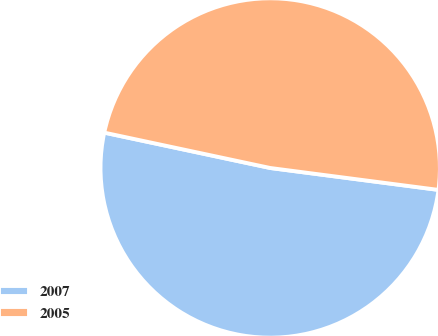<chart> <loc_0><loc_0><loc_500><loc_500><pie_chart><fcel>2007<fcel>2005<nl><fcel>51.28%<fcel>48.72%<nl></chart> 